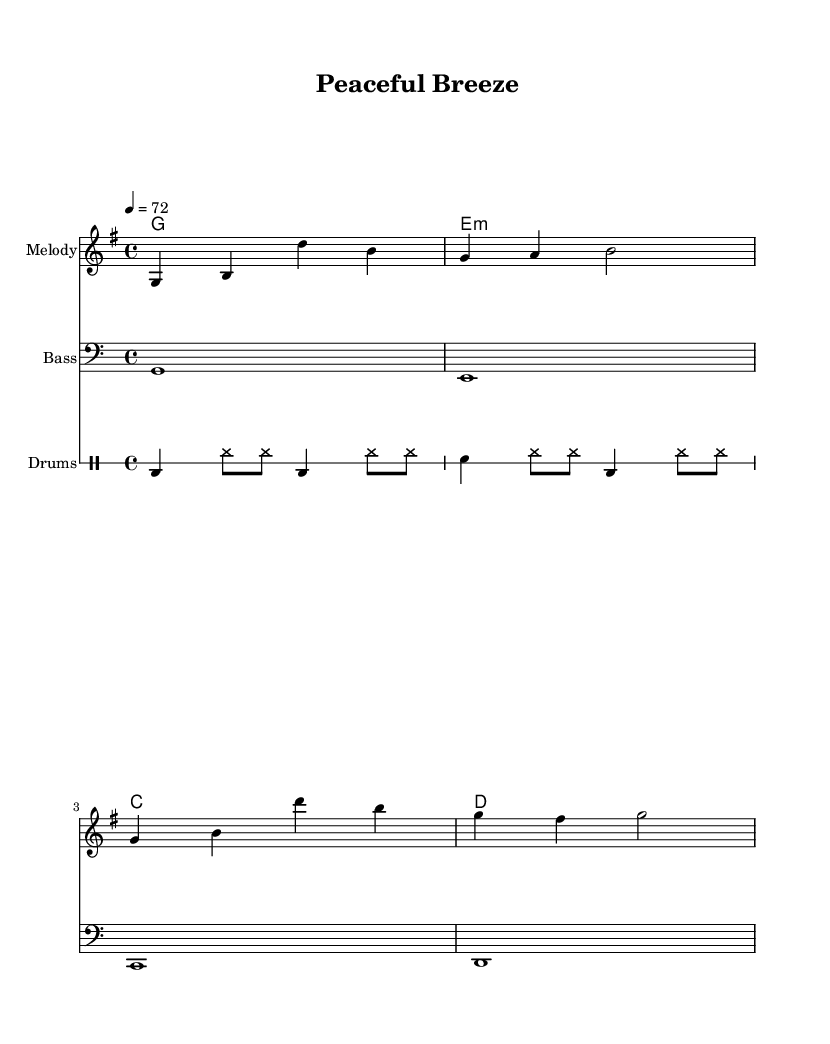What is the key signature of this music? The key signature indicates G major, which has one sharp (F#). This can be identified from the key signature at the beginning of the score.
Answer: G major What is the time signature of this music? The time signature is 4/4, which means there are four beats in each measure and each beat is a quarter note. This is seen at the beginning of the score next to the key signature.
Answer: 4/4 What is the tempo marking for this music? The tempo marking indicates a tempo of 72 beats per minute, which is noted in the score as "4 = 72." This tells the performer how fast to play the piece.
Answer: 72 How many measures are there in the melody? Counting the measures in the melody section, there are four measures total, each separated by a barline. This can be visually counted in the score.
Answer: 4 What type of drum is primarily featured in this piece? The drum part primarily features a bass drum, which is indicated by the "bd" marking in the drum pattern. It plays a key role in the reggae rhythm.
Answer: bass drum What is the structure of the harmonies used in the music? The structure consists of a sequence of four chords: G major, E minor, C major, and D major. This pattern is repeated throughout the piece and provides the harmonic foundation.
Answer: G, E minor, C, D How does the bass line relate to the harmony? The bass line plays the root notes of the harmonies indicated above it, thereby reinforcing the chord structure of the piece. Each bass note corresponds to the chord played.
Answer: It follows the root notes 